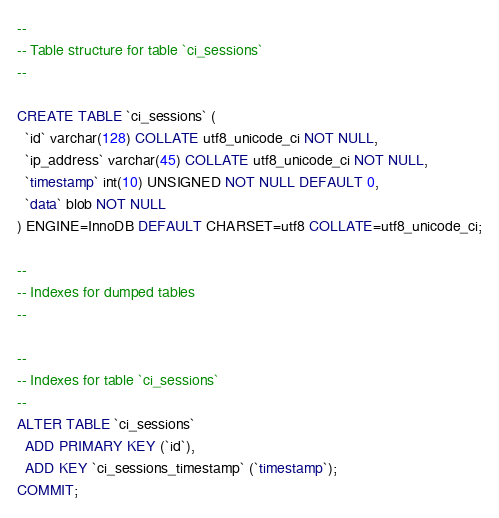<code> <loc_0><loc_0><loc_500><loc_500><_SQL_>--
-- Table structure for table `ci_sessions`
--

CREATE TABLE `ci_sessions` (
  `id` varchar(128) COLLATE utf8_unicode_ci NOT NULL,
  `ip_address` varchar(45) COLLATE utf8_unicode_ci NOT NULL,
  `timestamp` int(10) UNSIGNED NOT NULL DEFAULT 0,
  `data` blob NOT NULL
) ENGINE=InnoDB DEFAULT CHARSET=utf8 COLLATE=utf8_unicode_ci;

--
-- Indexes for dumped tables
--

--
-- Indexes for table `ci_sessions`
--
ALTER TABLE `ci_sessions`
  ADD PRIMARY KEY (`id`),
  ADD KEY `ci_sessions_timestamp` (`timestamp`);
COMMIT;
</code> 